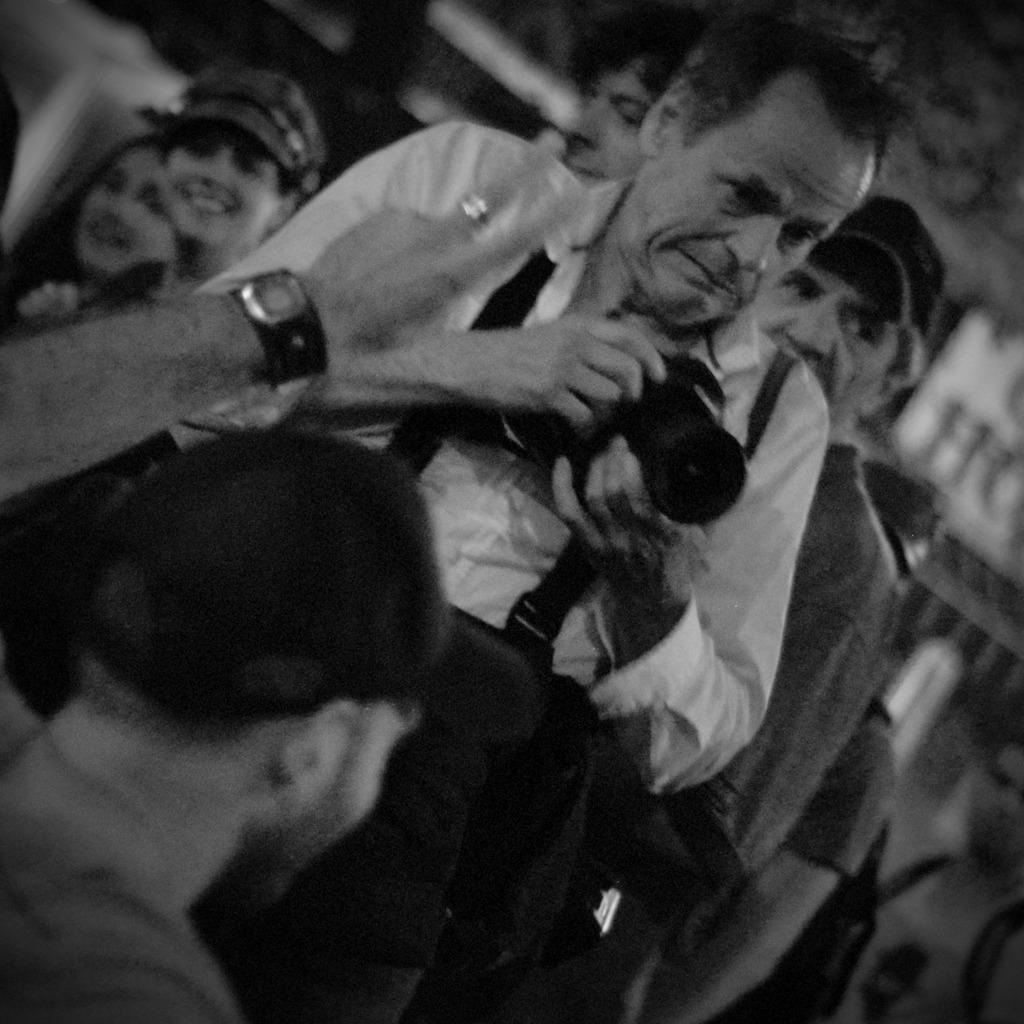What is the color scheme of the image? The image is black and white. What is the man in the image doing? The man is holding a camera in the image. Can you describe the position of the second man in the image? There is another man in the left bottom of the image. What can be seen in the background of the image? There are people visible in the background of the image. What note is the man holding the camera singing in the image? There is no indication in the image that the man is singing, nor is there any mention of a note. 